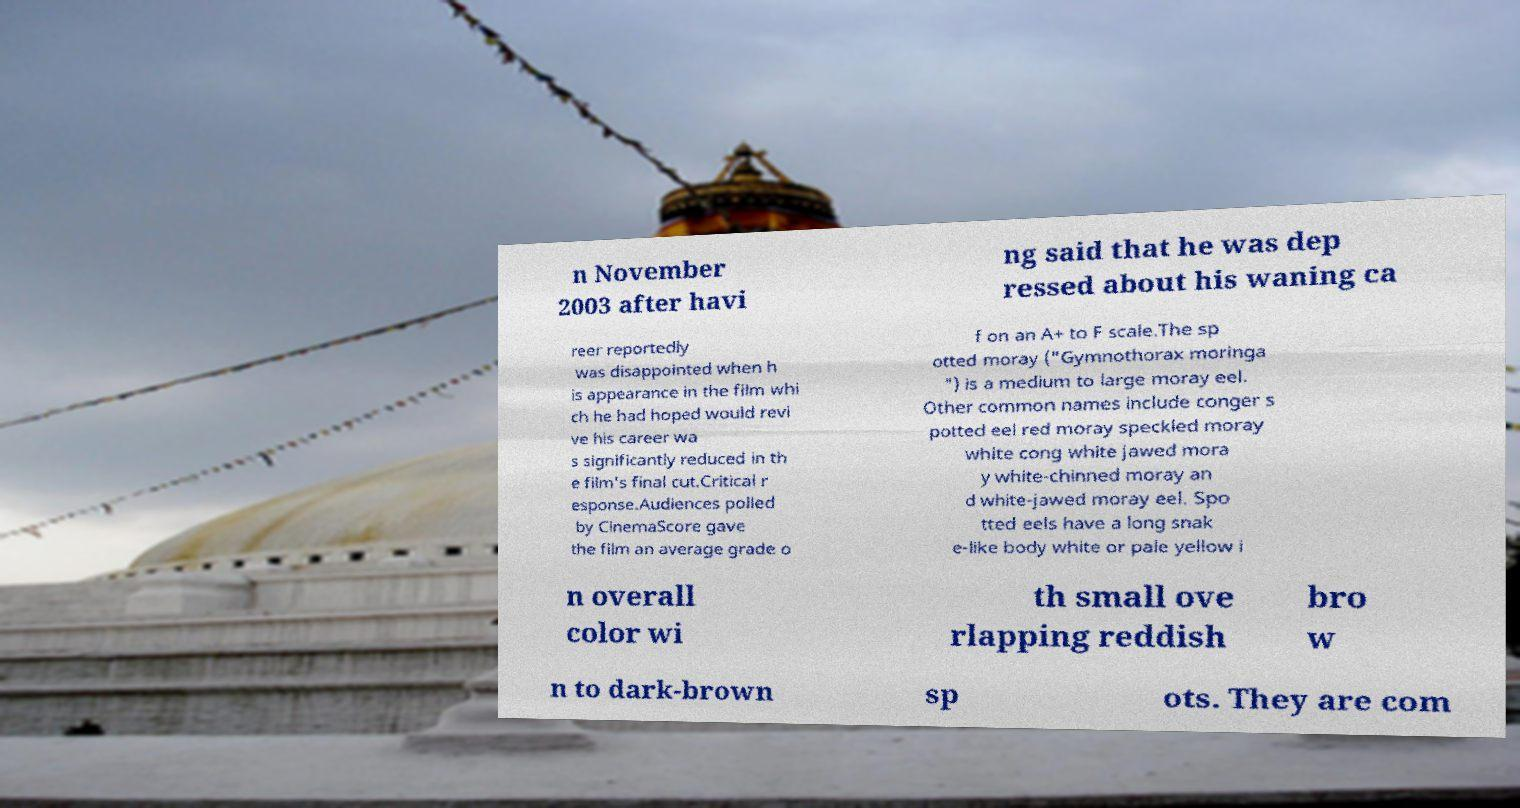I need the written content from this picture converted into text. Can you do that? n November 2003 after havi ng said that he was dep ressed about his waning ca reer reportedly was disappointed when h is appearance in the film whi ch he had hoped would revi ve his career wa s significantly reduced in th e film's final cut.Critical r esponse.Audiences polled by CinemaScore gave the film an average grade o f on an A+ to F scale.The sp otted moray ("Gymnothorax moringa ") is a medium to large moray eel. Other common names include conger s potted eel red moray speckled moray white cong white jawed mora y white-chinned moray an d white-jawed moray eel. Spo tted eels have a long snak e-like body white or pale yellow i n overall color wi th small ove rlapping reddish bro w n to dark-brown sp ots. They are com 